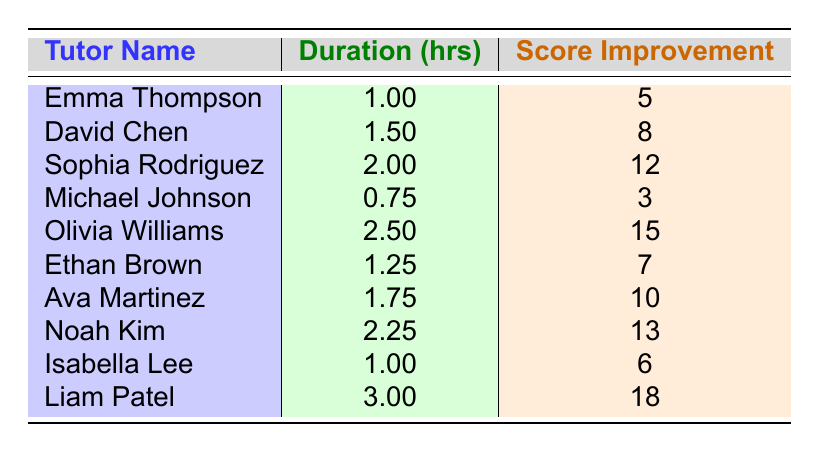What is the exam score improvement for Liam Patel? According to the table, Liam Patel’s exam score improvement is listed directly alongside his name, which shows an improvement of 18.
Answer: 18 Which tutor has the longest session duration? The longest session duration shown in the table is for Liam Patel, who had a session of 3 hours.
Answer: Liam Patel How much score improvement did Noah Kim achieve compared to Michael Johnson? Noah Kim improved his score by 13, whereas Michael Johnson only improved his score by 3. To find the difference, subtract Michael Johnson's score from Noah Kim's score: 13 - 3 = 10.
Answer: 10 What is the average exam score improvement for all the tutors? To find the average, sum all the score improvements: (5 + 8 + 12 + 3 + 15 + 7 + 10 + 13 + 6 + 18) = 93. There are 10 tutors, so divide by 10: 93 / 10 = 9.3.
Answer: 9.3 Is there a tutor with a session duration shorter than 1 hour? Looking through the table, the shortest session duration is Michael Johnson with 0.75 hours. Since this is less than 1 hour, the answer is yes.
Answer: Yes Which tutor had the highest score improvement in relation to their session duration? To find this, calculate the score improvement per hour for each tutor. Olivia Williams has 15/2.5 = 6, Liam Patel has 18/3 = 6, but Sophia Rodriguez has 12/2 = 6, and so does Noah Kim with 13/2.25 ≈ 5.78, and David Chen has 8/1.5 ≈ 5.33. Therefore, the highest score improvement per hour values are tied for Olivia Williams, Liam Patel, and Sophia Rodriguez at 6.
Answer: Olivia Williams, Liam Patel, and Sophia Rodriguez What is the total score improvement of tutors who conducted sessions longer than 2 hours? The tutors with sessions longer than 2 hours are Olivia Williams (15) and Liam Patel (18). Adding these together gives 15 + 18 = 33.
Answer: 33 How many tutors had a session duration of less than 1.5 hours? The tutors with a session duration less than 1.5 hours are Emma Thompson, Michael Johnson, and Ethan Brown. This totals to 3 tutors.
Answer: 3 Which tutor had the lowest exam score improvement? Michael Johnson has the lowest score improvement with 3.
Answer: Michael Johnson What is the difference in session duration between the tutor with the longest session and the tutor with the shortest? The longest session duration is Liam Patel's 3 hours, and the shortest is Michael Johnson's 0.75 hours. To find the difference, subtract: 3 - 0.75 = 2.25.
Answer: 2.25 